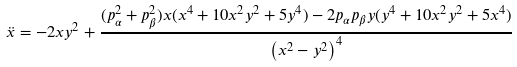Convert formula to latex. <formula><loc_0><loc_0><loc_500><loc_500>\ddot { x } = - 2 x y ^ { 2 } + { \frac { ( p _ { \alpha } ^ { 2 } + p _ { \beta } ^ { 2 } ) x ( x ^ { 4 } + 1 0 x ^ { 2 } y ^ { 2 } + 5 y ^ { 4 } ) - 2 p _ { \alpha } p _ { \beta } y ( y ^ { 4 } + 1 0 x ^ { 2 } y ^ { 2 } + 5 x ^ { 4 } ) } { \left ( x ^ { 2 } - y ^ { 2 } \right ) ^ { 4 } } }</formula> 